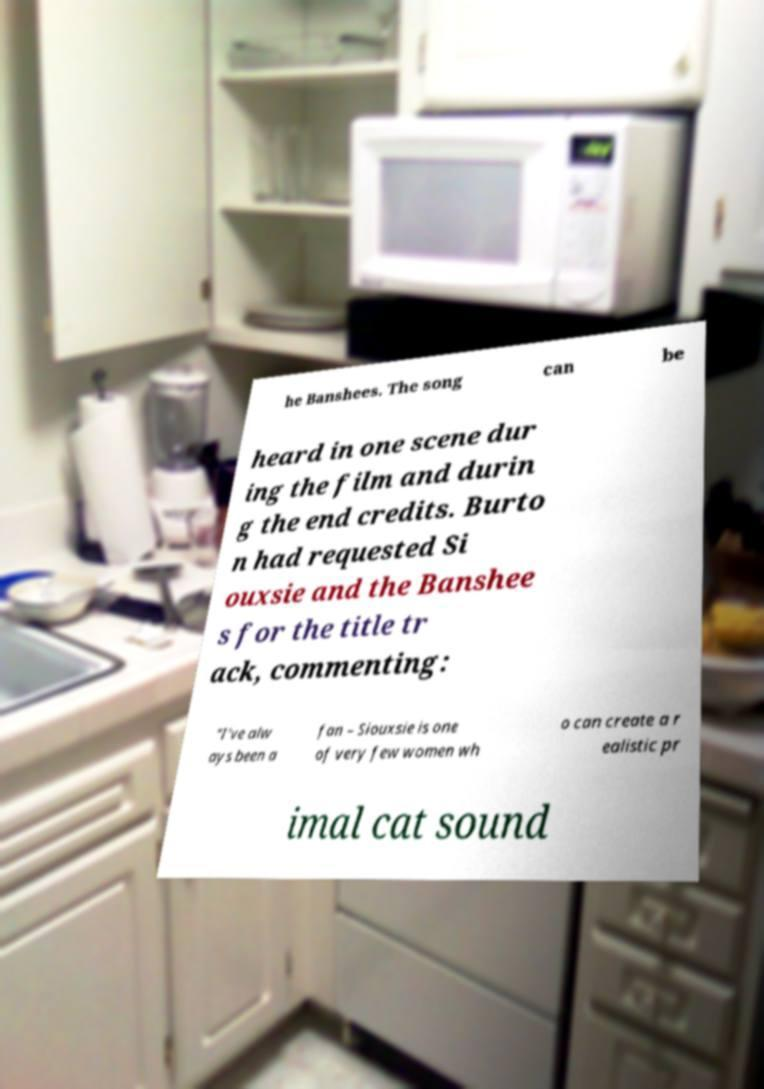There's text embedded in this image that I need extracted. Can you transcribe it verbatim? he Banshees. The song can be heard in one scene dur ing the film and durin g the end credits. Burto n had requested Si ouxsie and the Banshee s for the title tr ack, commenting: "I've alw ays been a fan – Siouxsie is one of very few women wh o can create a r ealistic pr imal cat sound 